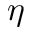Convert formula to latex. <formula><loc_0><loc_0><loc_500><loc_500>\eta</formula> 